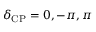<formula> <loc_0><loc_0><loc_500><loc_500>\delta _ { C P } = 0 , - \pi , \pi</formula> 